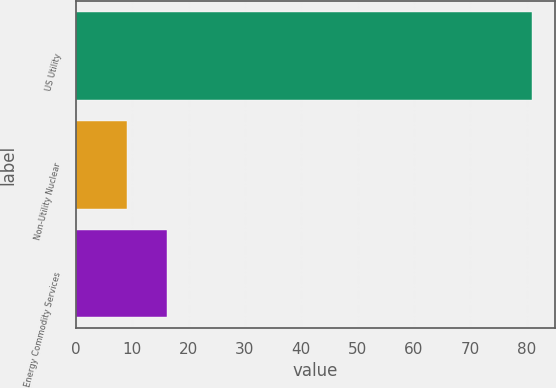Convert chart. <chart><loc_0><loc_0><loc_500><loc_500><bar_chart><fcel>US Utility<fcel>Non-Utility Nuclear<fcel>Energy Commodity Services<nl><fcel>81<fcel>9<fcel>16.2<nl></chart> 